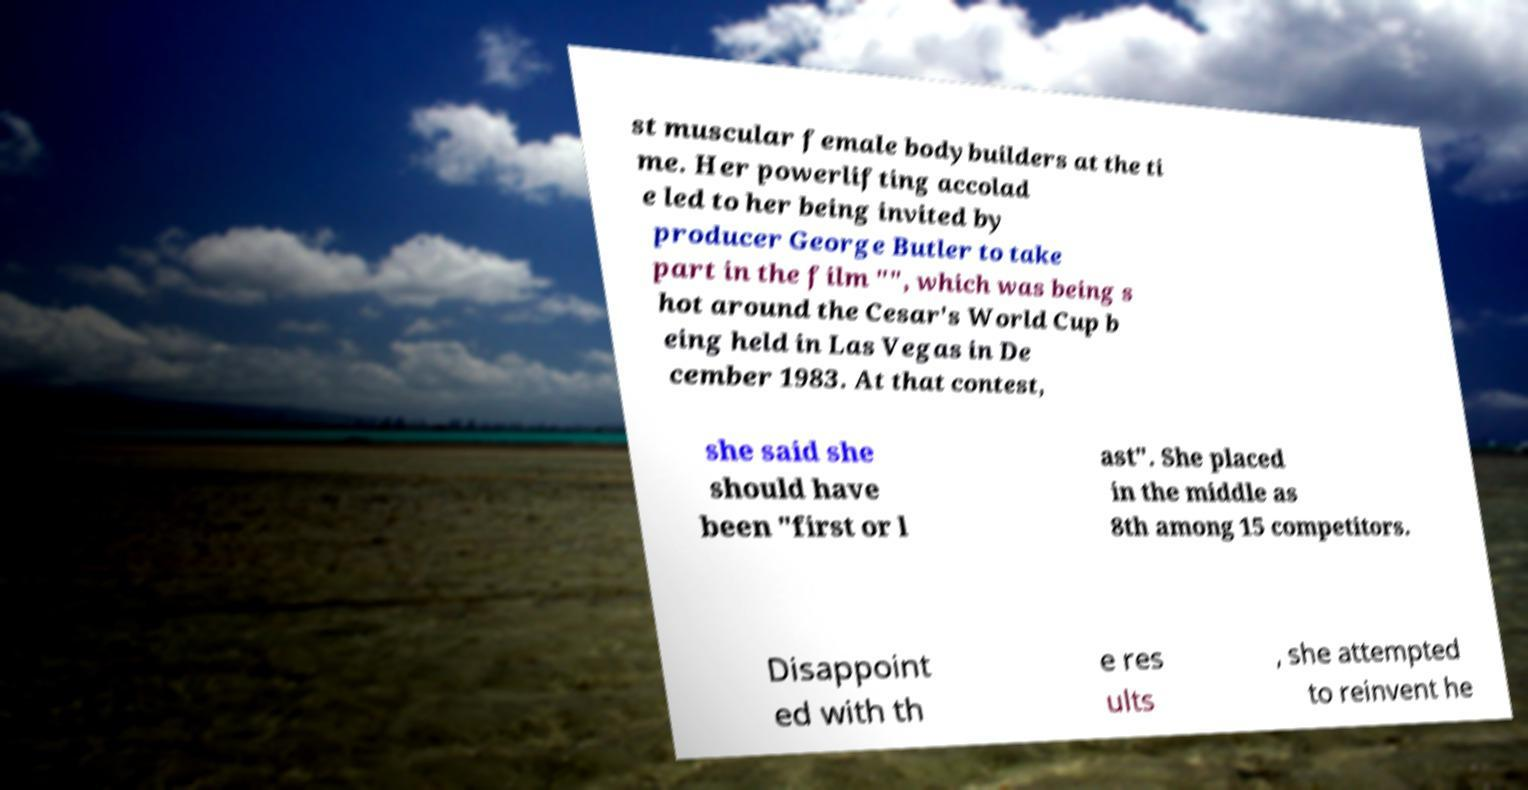Could you extract and type out the text from this image? st muscular female bodybuilders at the ti me. Her powerlifting accolad e led to her being invited by producer George Butler to take part in the film "", which was being s hot around the Cesar's World Cup b eing held in Las Vegas in De cember 1983. At that contest, she said she should have been "first or l ast". She placed in the middle as 8th among 15 competitors. Disappoint ed with th e res ults , she attempted to reinvent he 